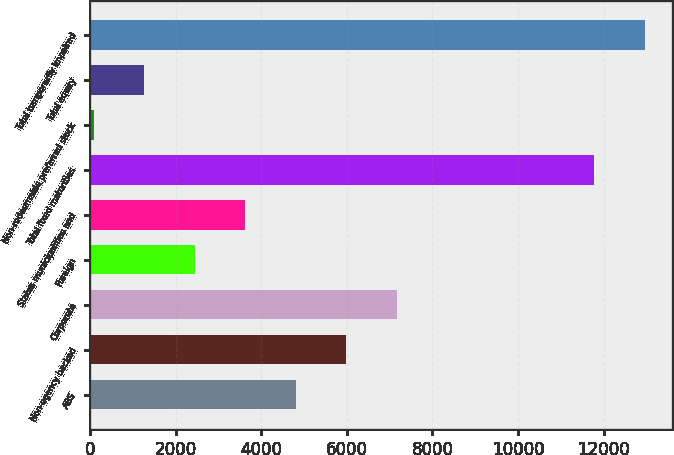Convert chart. <chart><loc_0><loc_0><loc_500><loc_500><bar_chart><fcel>ABS<fcel>Non-agency backed<fcel>Corporate<fcel>Foreign<fcel>States municipalities and<fcel>Total fixed maturities<fcel>Non-redeemable preferred stock<fcel>Total equity<fcel>Total temporarily impaired<nl><fcel>4808.6<fcel>5987<fcel>7165.4<fcel>2451.8<fcel>3630.2<fcel>11783<fcel>95<fcel>1273.4<fcel>12961.4<nl></chart> 